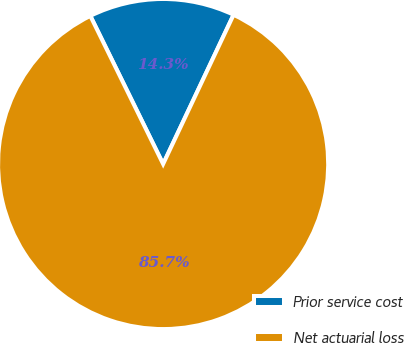<chart> <loc_0><loc_0><loc_500><loc_500><pie_chart><fcel>Prior service cost<fcel>Net actuarial loss<nl><fcel>14.29%<fcel>85.71%<nl></chart> 